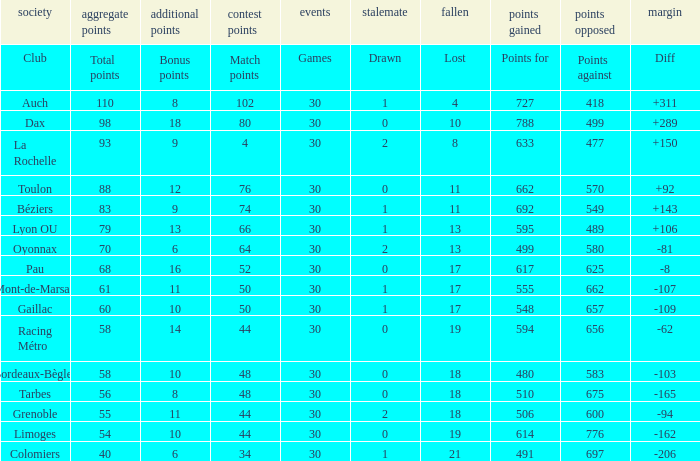Would you mind parsing the complete table? {'header': ['society', 'aggregate points', 'additional points', 'contest points', 'events', 'stalemate', 'fallen', 'points gained', 'points opposed', 'margin'], 'rows': [['Club', 'Total points', 'Bonus points', 'Match points', 'Games', 'Drawn', 'Lost', 'Points for', 'Points against', 'Diff'], ['Auch', '110', '8', '102', '30', '1', '4', '727', '418', '+311'], ['Dax', '98', '18', '80', '30', '0', '10', '788', '499', '+289'], ['La Rochelle', '93', '9', '4', '30', '2', '8', '633', '477', '+150'], ['Toulon', '88', '12', '76', '30', '0', '11', '662', '570', '+92'], ['Béziers', '83', '9', '74', '30', '1', '11', '692', '549', '+143'], ['Lyon OU', '79', '13', '66', '30', '1', '13', '595', '489', '+106'], ['Oyonnax', '70', '6', '64', '30', '2', '13', '499', '580', '-81'], ['Pau', '68', '16', '52', '30', '0', '17', '617', '625', '-8'], ['Mont-de-Marsan', '61', '11', '50', '30', '1', '17', '555', '662', '-107'], ['Gaillac', '60', '10', '50', '30', '1', '17', '548', '657', '-109'], ['Racing Métro', '58', '14', '44', '30', '0', '19', '594', '656', '-62'], ['Bordeaux-Bègles', '58', '10', '48', '30', '0', '18', '480', '583', '-103'], ['Tarbes', '56', '8', '48', '30', '0', '18', '510', '675', '-165'], ['Grenoble', '55', '11', '44', '30', '2', '18', '506', '600', '-94'], ['Limoges', '54', '10', '44', '30', '0', '19', '614', '776', '-162'], ['Colomiers', '40', '6', '34', '30', '1', '21', '491', '697', '-206']]} What is the number of games for a club that has a value of 595 for points for? 30.0. 